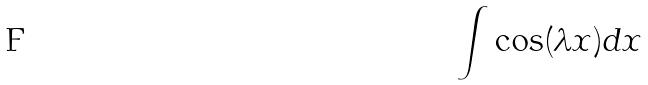Convert formula to latex. <formula><loc_0><loc_0><loc_500><loc_500>\int \cos ( \lambda x ) d x</formula> 